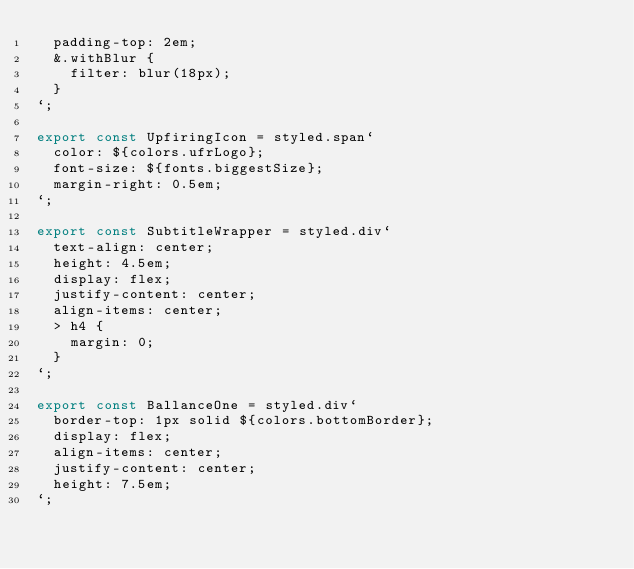<code> <loc_0><loc_0><loc_500><loc_500><_JavaScript_>  padding-top: 2em;
  &.withBlur {
    filter: blur(18px);
  }
`;

export const UpfiringIcon = styled.span`
  color: ${colors.ufrLogo};
  font-size: ${fonts.biggestSize};
  margin-right: 0.5em;
`;

export const SubtitleWrapper = styled.div`
  text-align: center;
  height: 4.5em;
  display: flex;
  justify-content: center;
  align-items: center;
  > h4 {
    margin: 0;
  }
`;

export const BallanceOne = styled.div`
  border-top: 1px solid ${colors.bottomBorder};
  display: flex;
  align-items: center;
  justify-content: center;
  height: 7.5em;
`;
</code> 